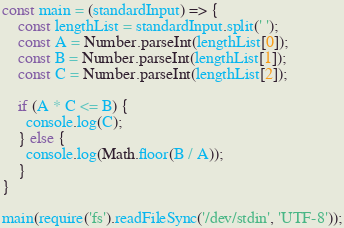Convert code to text. <code><loc_0><loc_0><loc_500><loc_500><_JavaScript_>const main = (standardInput) => {
    const lengthList = standardInput.split(' ');
    const A = Number.parseInt(lengthList[0]);
    const B = Number.parseInt(lengthList[1]);
    const C = Number.parseInt(lengthList[2]);
  
  	if (A * C <= B) {
      console.log(C);
    } else {
      console.log(Math.floor(B / A));
    }
}

main(require('fs').readFileSync('/dev/stdin', 'UTF-8'));
</code> 